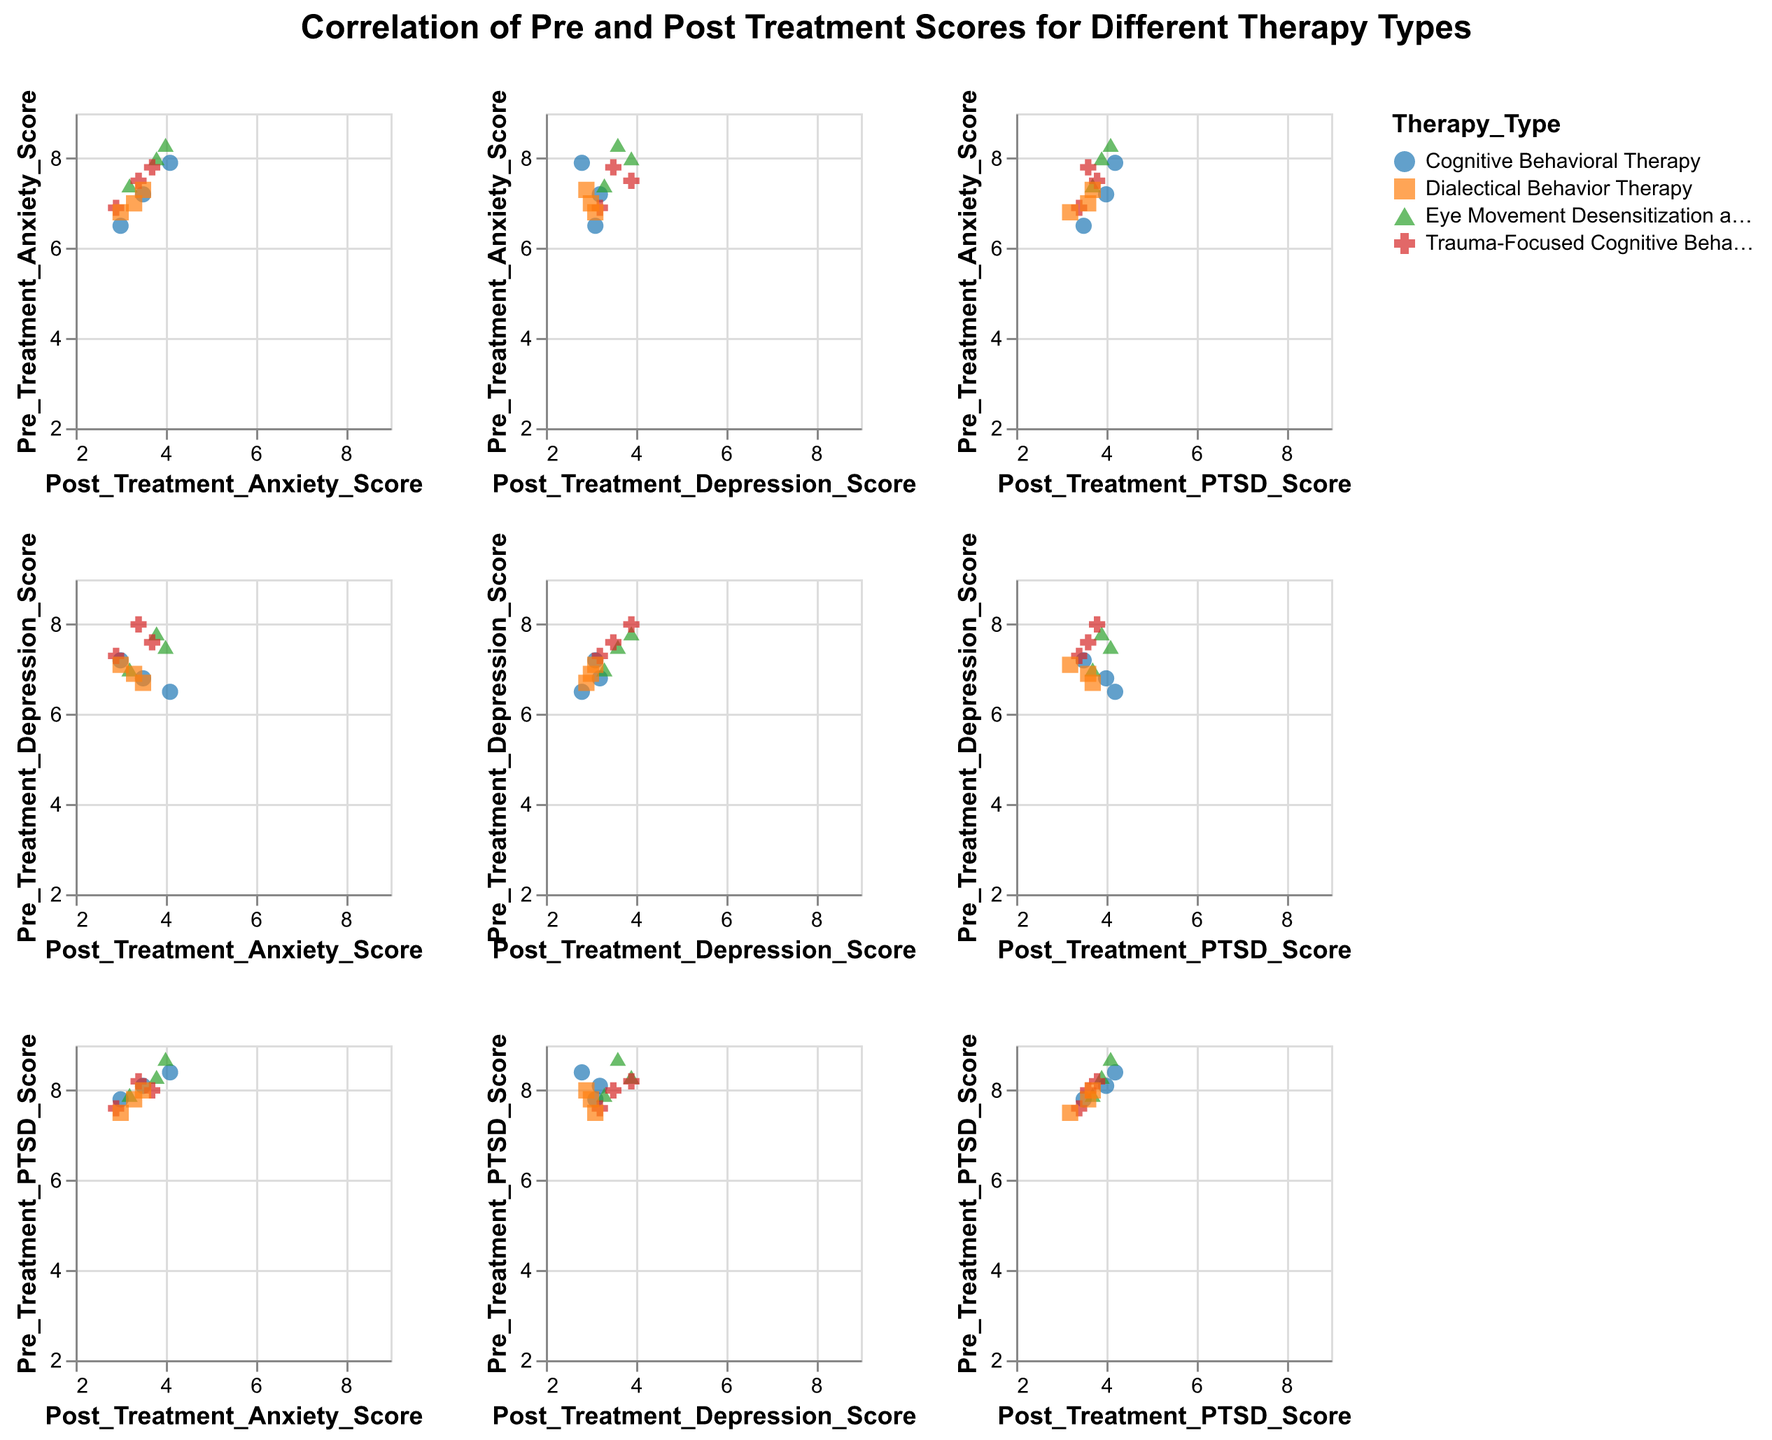What is the title of the figure? The title can be found at the top of the figure. It reads: "Correlation of Pre and Post Treatment Scores for Different Therapy Types".
Answer: Correlation of Pre and Post Treatment Scores for Different Therapy Types What types of therapies are included in the figure? Check the color legend or the points' color and shape to see the different categories listed for therapy types.
Answer: Cognitive Behavioral Therapy, Eye Movement Desensitization and Reprocessing, Trauma-Focused Cognitive Behavioral Therapy, Dialectical Behavior Therapy How many data points are shown for Cognitive Behavioral Therapy? Look for the points colored and shaped according to the legend for Cognitive Behavioral Therapy across all plots. Count the number of such points. There are three instances for Cognitive Behavioral Therapy.
Answer: 3 What is the average post-treatment anxiety score for Trauma-Focused Cognitive Behavioral Therapy? Identify all the data points corresponding to Trauma-Focused Cognitive Behavioral Therapy, check their Post_Treatment_Anxiety_Score values, and calculate the average.
For Trauma-Focused Cognitive Behavioral Therapy: (3.4 + 2.9 + 3.7)/3 = 3.33.
Answer: 3.33 What is the difference between the pre-treatment and post-treatment PTSD scores for the data point with the lowest pre-treatment PTSD score? Identify the point with the lowest pre-treatment PTSD score, then find its corresponding post-treatment PTSD score. Subtract post-treatment score from the pre-treatment score. The lowest pre-treatment PTSD score is 7.5 (Dialectical Behavior Therapy), and corresponding post-treatment score is 3.2. Hence, the difference is 7.5 - 3.2.
Answer: 4.3 Which therapy type showed the most significant reduction in depression scores based on the average difference between pre-treatment and post-treatment scores? Calculate the average difference for each therapy type by subtracting post-treatment scores from pre-treatment scores for depression. Find the therapy type with the highest average reduction.
Answer: Cognitive Behavioral Therapy Is the reduction in anxiety scores greater for Eye Movement Desensitization and Reprocessing or for Cognitive Behavioral Therapy? Find the average reduction in anxiety scores for both therapy types by subtracting post-treatment scores from pre-treatment scores. Compare the averages.
For Eye Movement Desensitization and Reprocessing: (8.3 - 4.0 + 7.4 - 3.2 + 8.0 - 3.8)/3 = 4.9
For Cognitive Behavioral Therapy: (7.2 - 3.5 + 6.5 - 3.0 + 7.9 - 4.1)/3 = 4.0
Answer: Eye Movement Desensitization and Reprocessing Is there a visible correlation between pre-treatment and post-treatment scores for any therapy type? Check the scatter plots for clustering patterns, trends, or alignments that indicate correlations between pre-treatment and post-treatment scores for each therapy type. There appears to be a general downward trend in post-treatment scores compared to pre-treatment scores for all therapy types, indicating improvement.
Answer: Yes Do all therapy types show improvement in PTSD scores post-treatment? Examine the scatter plots for PTSD scores, identify the trend from pre-treatment to post-treatment scores for each therapy type. All therapy types show post-treatment PTSD scores lower than pre-treatment, indicating improvement.
Answer: Yes 